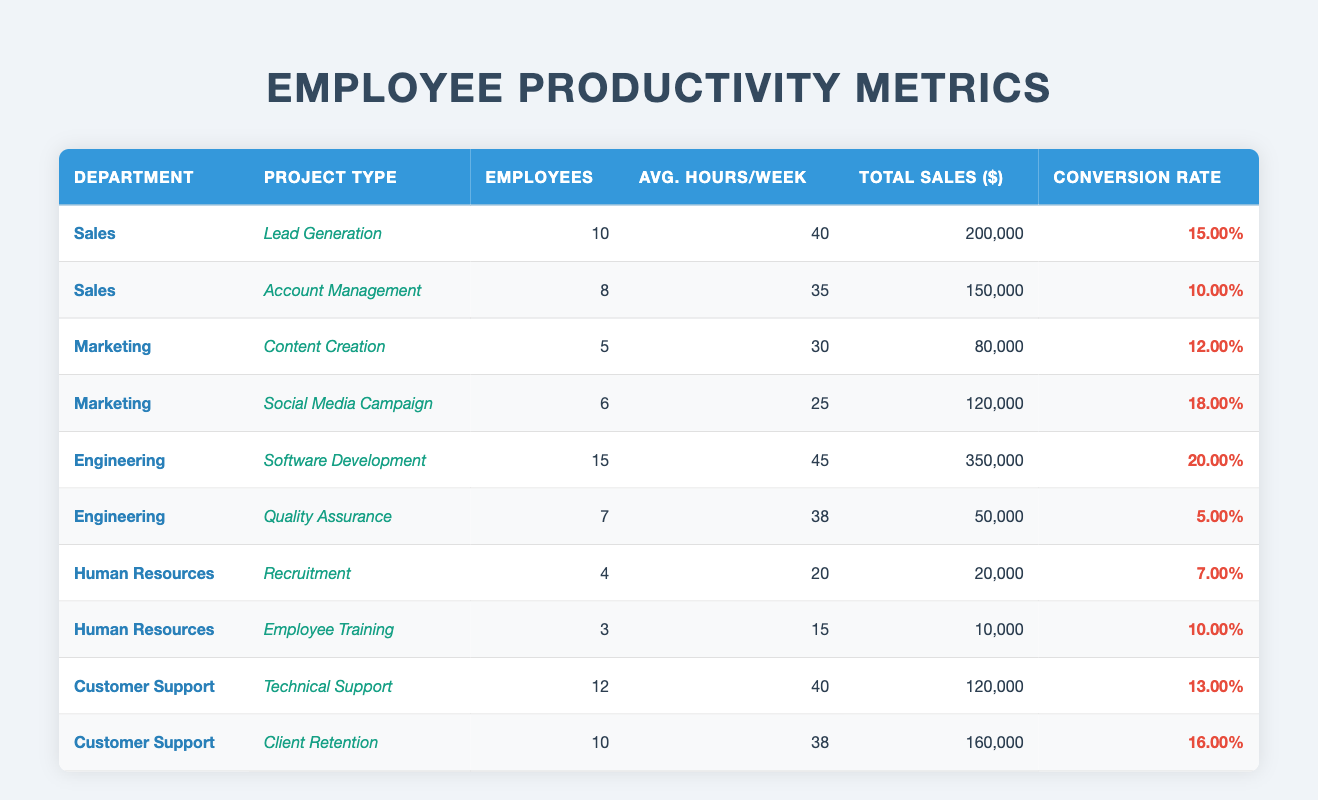What is the total sales for the Engineering department on Software Development? The table shows that the Engineering department has a project type of Software Development, which generated total sales of $350,000.
Answer: $350,000 How many employees work in the Customer Support department? Looking at the table, the Customer Support department has a total of 12 employees working on Technical Support and 10 employees working on Client Retention. Therefore, the total is 12 + 10 = 22 employees.
Answer: 22 What is the conversion rate for the Marketing department in the Social Media Campaign? The table states that the Social Media Campaign from the Marketing department has a conversion rate of 18%.
Answer: 18% Which department has the highest average hours per week for its employees? By examining the average hours per week, Engineering has 45 hours for Software Development, which is the highest compared to other departments.
Answer: Engineering What is the average total sales generated by the projects in the Human Resources department? The total sales for Recruitment is $20,000, and for Employee Training, it's $10,000. Adding these gives $30,000. To find the average, we divide by the number of projects (2), so $30,000 / 2 = $15,000.
Answer: $15,000 True or False: The Sales department has a higher conversion rate for Lead Generation than the Engineering department for Software Development. The Sales department's Lead Generation conversion rate is 15%, while Engineering's Software Development conversion rate is 20%. Since 15% is less than 20%, the statement is false.
Answer: False What is the total number of employees across all departments? By summing the employees listed for each department: 10 + 8 (Sales) + 5 + 6 (Marketing) + 15 + 7 (Engineering) + 4 + 3 (HR) + 12 + 10 (Customer Support), the total number comes to 10 + 8 + 5 + 6 + 15 + 7 + 4 + 3 + 12 + 10 = 70 employees total.
Answer: 70 What is the difference in average hours per week between the highest and lowest project type in the Engineering department? The highest average hours in Engineering is 45 (Software Development) and the lowest is 38 (Quality Assurance). Therefore, the difference is 45 - 38 = 7 hours.
Answer: 7 hours Which project type in the Marketing department generated the lowest total sales? The project types are Content Creation ($80,000) and Social Media Campaign ($120,000). Since $80,000 is less than $120,000, Content Creation generated the lowest total sales.
Answer: Content Creation How many more total sales did the Customer Support department generate in Client Retention compared to Technical Support? The Client Retention brought in $160,000, while Technical Support brought in $120,000. The difference is $160,000 - $120,000 = $40,000.
Answer: $40,000 